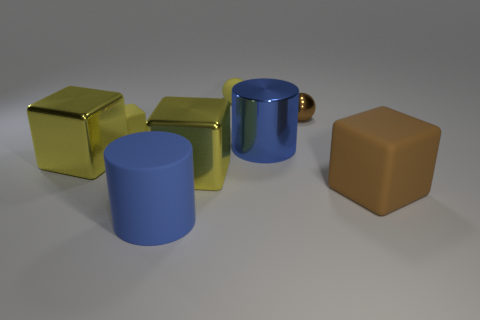How many yellow blocks must be subtracted to get 1 yellow blocks? 2 Subtract all brown rubber cubes. How many cubes are left? 3 Subtract 3 cubes. How many cubes are left? 1 Subtract all yellow cubes. How many cubes are left? 1 Add 2 large cyan metallic objects. How many objects exist? 10 Subtract 0 green cylinders. How many objects are left? 8 Subtract all spheres. How many objects are left? 6 Subtract all brown cubes. Subtract all blue cylinders. How many cubes are left? 3 Subtract all brown balls. How many blue cubes are left? 0 Subtract all purple things. Subtract all yellow things. How many objects are left? 4 